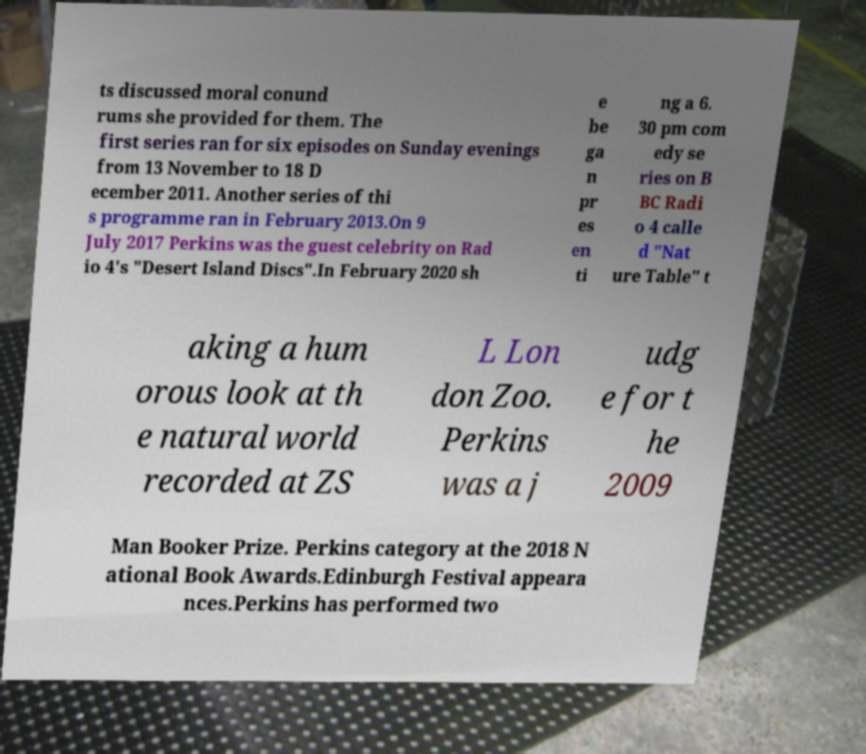Could you assist in decoding the text presented in this image and type it out clearly? ts discussed moral conund rums she provided for them. The first series ran for six episodes on Sunday evenings from 13 November to 18 D ecember 2011. Another series of thi s programme ran in February 2013.On 9 July 2017 Perkins was the guest celebrity on Rad io 4's "Desert Island Discs".In February 2020 sh e be ga n pr es en ti ng a 6. 30 pm com edy se ries on B BC Radi o 4 calle d "Nat ure Table" t aking a hum orous look at th e natural world recorded at ZS L Lon don Zoo. Perkins was a j udg e for t he 2009 Man Booker Prize. Perkins category at the 2018 N ational Book Awards.Edinburgh Festival appeara nces.Perkins has performed two 